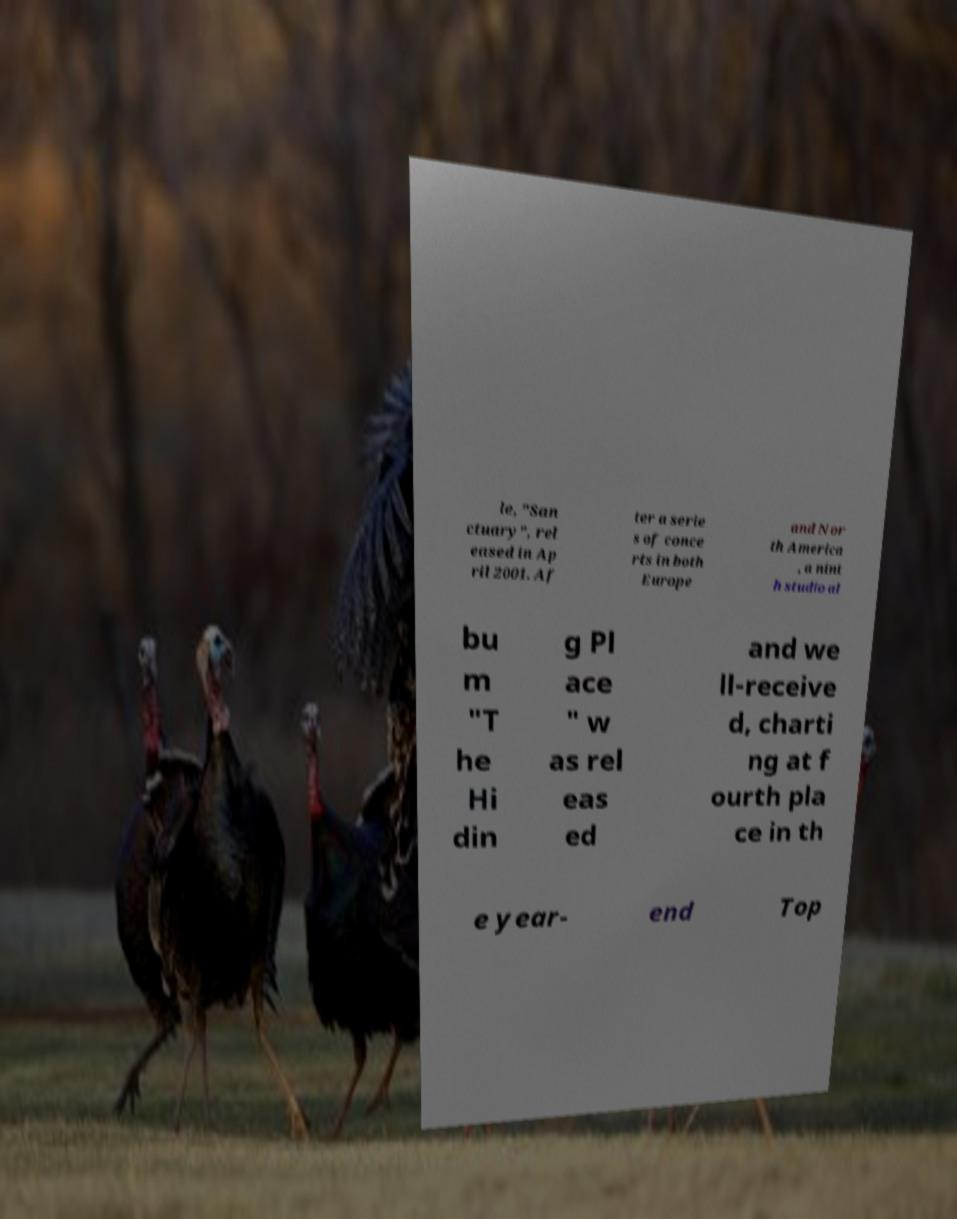For documentation purposes, I need the text within this image transcribed. Could you provide that? le, "San ctuary", rel eased in Ap ril 2001. Af ter a serie s of conce rts in both Europe and Nor th America , a nint h studio al bu m "T he Hi din g Pl ace " w as rel eas ed and we ll-receive d, charti ng at f ourth pla ce in th e year- end Top 